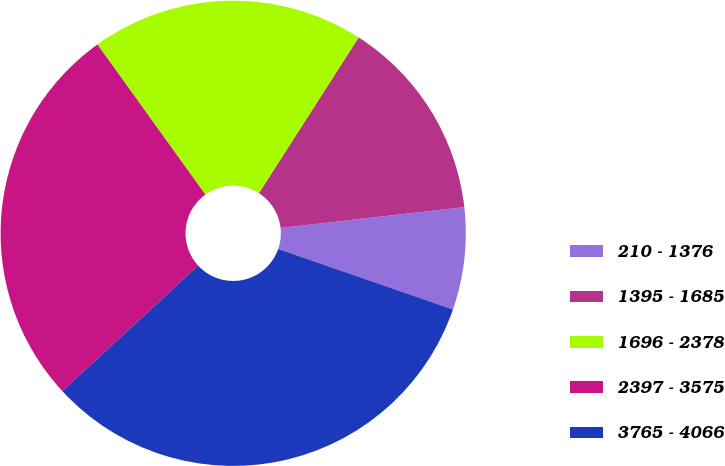Convert chart to OTSL. <chart><loc_0><loc_0><loc_500><loc_500><pie_chart><fcel>210 - 1376<fcel>1395 - 1685<fcel>1696 - 2378<fcel>2397 - 3575<fcel>3765 - 4066<nl><fcel>7.11%<fcel>14.14%<fcel>18.99%<fcel>26.95%<fcel>32.82%<nl></chart> 